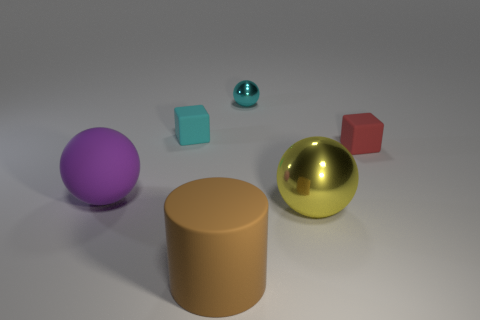Subtract all yellow spheres. How many spheres are left? 2 Subtract all cyan cubes. How many cubes are left? 1 Add 2 large yellow metal things. How many objects exist? 8 Subtract all cylinders. How many objects are left? 5 Subtract 3 spheres. How many spheres are left? 0 Add 2 cyan shiny balls. How many cyan shiny balls exist? 3 Subtract 0 gray blocks. How many objects are left? 6 Subtract all red balls. Subtract all red cylinders. How many balls are left? 3 Subtract all blue cubes. How many blue cylinders are left? 0 Subtract all green rubber balls. Subtract all cyan shiny balls. How many objects are left? 5 